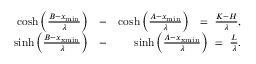Convert formula to latex. <formula><loc_0><loc_0><loc_500><loc_500>\begin{array} { r l r } { \cosh \left ( \frac { B - x _ { \min } } { \lambda } \right ) } & { - } & { \cosh \left ( \frac { A - x _ { \min } } { \lambda } \right ) = \frac { K - H } { \lambda } , } \\ { \sinh \left ( \frac { B - x _ { x \min } } { \lambda } \right ) } & { - } & { \sinh \left ( \frac { A - x _ { x \min } } { \lambda } \right ) = \frac { L } { \lambda } . } \end{array}</formula> 